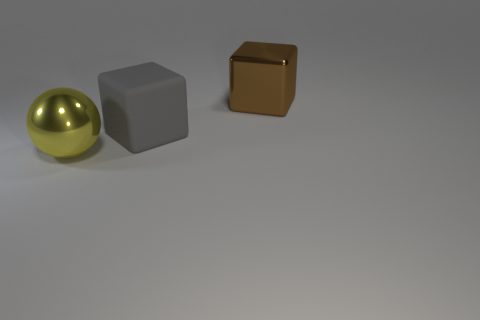Add 1 large spheres. How many objects exist? 4 Subtract all balls. How many objects are left? 2 Add 1 large gray matte cubes. How many large gray matte cubes are left? 2 Add 2 gray matte things. How many gray matte things exist? 3 Subtract 0 green blocks. How many objects are left? 3 Subtract all big yellow spheres. Subtract all large yellow balls. How many objects are left? 1 